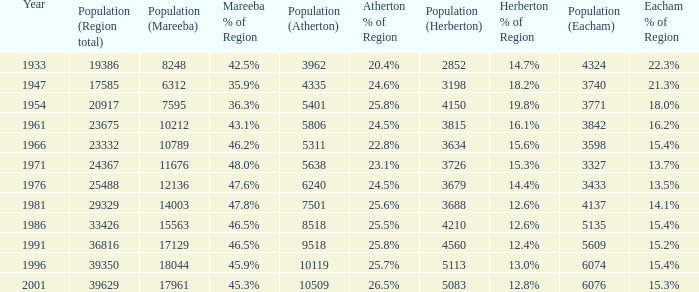How many figures are given for the region's total in 1947? 1.0. Give me the full table as a dictionary. {'header': ['Year', 'Population (Region total)', 'Population (Mareeba)', 'Mareeba % of Region', 'Population (Atherton)', 'Atherton % of Region', 'Population (Herberton)', 'Herberton % of Region', 'Population (Eacham)', 'Eacham % of Region'], 'rows': [['1933', '19386', '8248', '42.5%', '3962', '20.4%', '2852', '14.7%', '4324', '22.3%'], ['1947', '17585', '6312', '35.9%', '4335', '24.6%', '3198', '18.2%', '3740', '21.3%'], ['1954', '20917', '7595', '36.3%', '5401', '25.8%', '4150', '19.8%', '3771', '18.0%'], ['1961', '23675', '10212', '43.1%', '5806', '24.5%', '3815', '16.1%', '3842', '16.2%'], ['1966', '23332', '10789', '46.2%', '5311', '22.8%', '3634', '15.6%', '3598', '15.4%'], ['1971', '24367', '11676', '48.0%', '5638', '23.1%', '3726', '15.3%', '3327', '13.7%'], ['1976', '25488', '12136', '47.6%', '6240', '24.5%', '3679', '14.4%', '3433', '13.5%'], ['1981', '29329', '14003', '47.8%', '7501', '25.6%', '3688', '12.6%', '4137', '14.1%'], ['1986', '33426', '15563', '46.5%', '8518', '25.5%', '4210', '12.6%', '5135', '15.4%'], ['1991', '36816', '17129', '46.5%', '9518', '25.8%', '4560', '12.4%', '5609', '15.2%'], ['1996', '39350', '18044', '45.9%', '10119', '25.7%', '5113', '13.0%', '6074', '15.4%'], ['2001', '39629', '17961', '45.3%', '10509', '26.5%', '5083', '12.8%', '6076', '15.3%']]} 